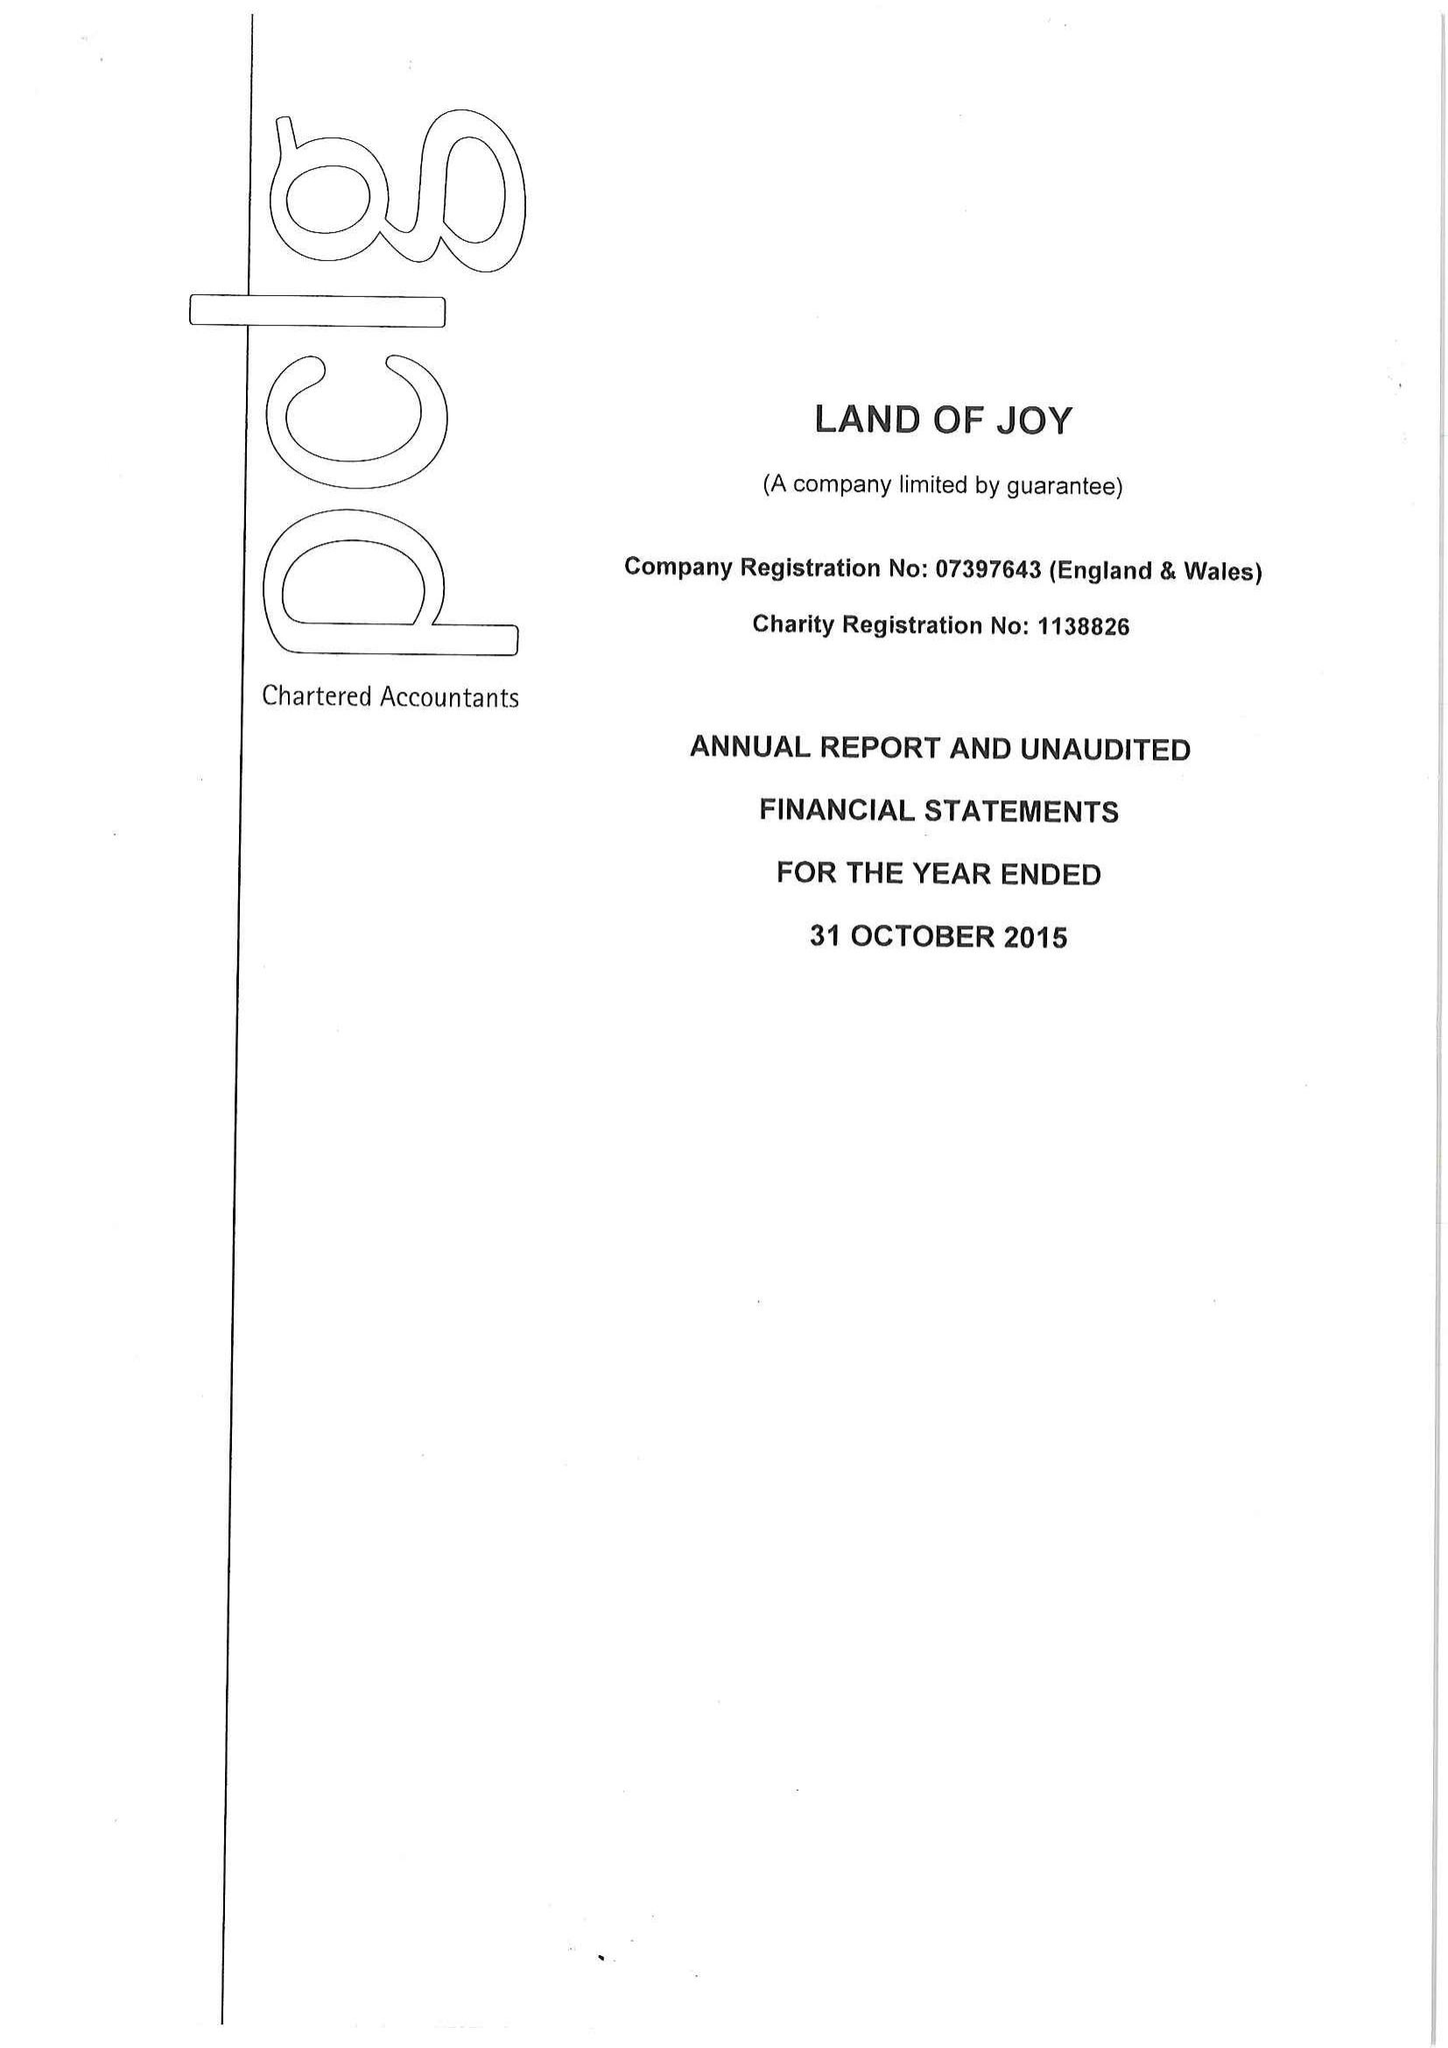What is the value for the address__street_line?
Answer the question using a single word or phrase. GREENHAUGH 